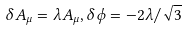Convert formula to latex. <formula><loc_0><loc_0><loc_500><loc_500>\delta A _ { \mu } = \lambda A _ { \mu } , \delta \phi = - 2 \lambda / \sqrt { 3 }</formula> 